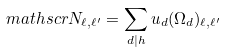Convert formula to latex. <formula><loc_0><loc_0><loc_500><loc_500>\ m a t h s c r { N } _ { \ell , \ell ^ { \prime } } = \sum _ { d | h } u _ { d } ( \Omega _ { d } ) _ { \ell , \ell ^ { \prime } }</formula> 